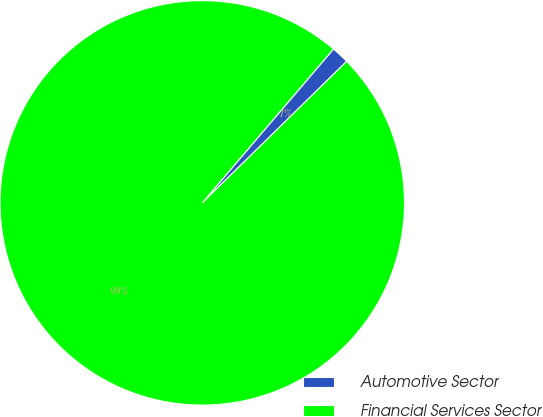Convert chart. <chart><loc_0><loc_0><loc_500><loc_500><pie_chart><fcel>Automotive Sector<fcel>Financial Services Sector<nl><fcel>1.42%<fcel>98.58%<nl></chart> 